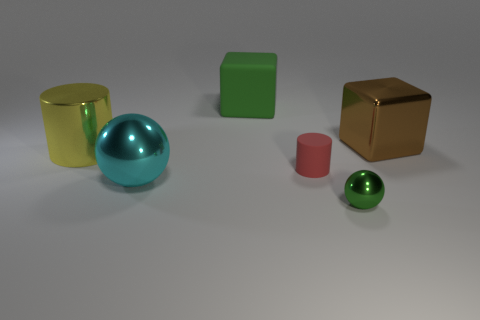Add 4 tiny cyan rubber things. How many objects exist? 10 Subtract all cylinders. How many objects are left? 4 Subtract all large green cubes. Subtract all big metallic blocks. How many objects are left? 4 Add 1 large green rubber cubes. How many large green rubber cubes are left? 2 Add 1 large rubber cylinders. How many large rubber cylinders exist? 1 Subtract 0 gray blocks. How many objects are left? 6 